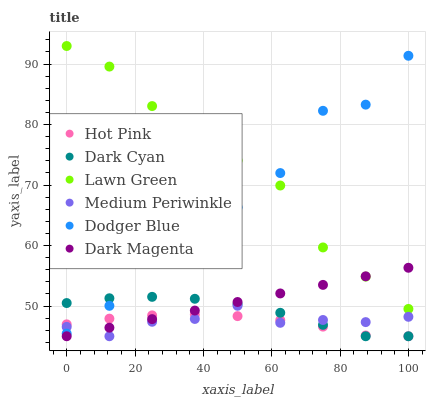Does Hot Pink have the minimum area under the curve?
Answer yes or no. Yes. Does Lawn Green have the maximum area under the curve?
Answer yes or no. Yes. Does Dark Magenta have the minimum area under the curve?
Answer yes or no. No. Does Dark Magenta have the maximum area under the curve?
Answer yes or no. No. Is Dark Magenta the smoothest?
Answer yes or no. Yes. Is Dodger Blue the roughest?
Answer yes or no. Yes. Is Hot Pink the smoothest?
Answer yes or no. No. Is Hot Pink the roughest?
Answer yes or no. No. Does Dark Magenta have the lowest value?
Answer yes or no. Yes. Does Dodger Blue have the lowest value?
Answer yes or no. No. Does Lawn Green have the highest value?
Answer yes or no. Yes. Does Dark Magenta have the highest value?
Answer yes or no. No. Is Dark Magenta less than Dodger Blue?
Answer yes or no. Yes. Is Lawn Green greater than Dark Cyan?
Answer yes or no. Yes. Does Dark Magenta intersect Hot Pink?
Answer yes or no. Yes. Is Dark Magenta less than Hot Pink?
Answer yes or no. No. Is Dark Magenta greater than Hot Pink?
Answer yes or no. No. Does Dark Magenta intersect Dodger Blue?
Answer yes or no. No. 